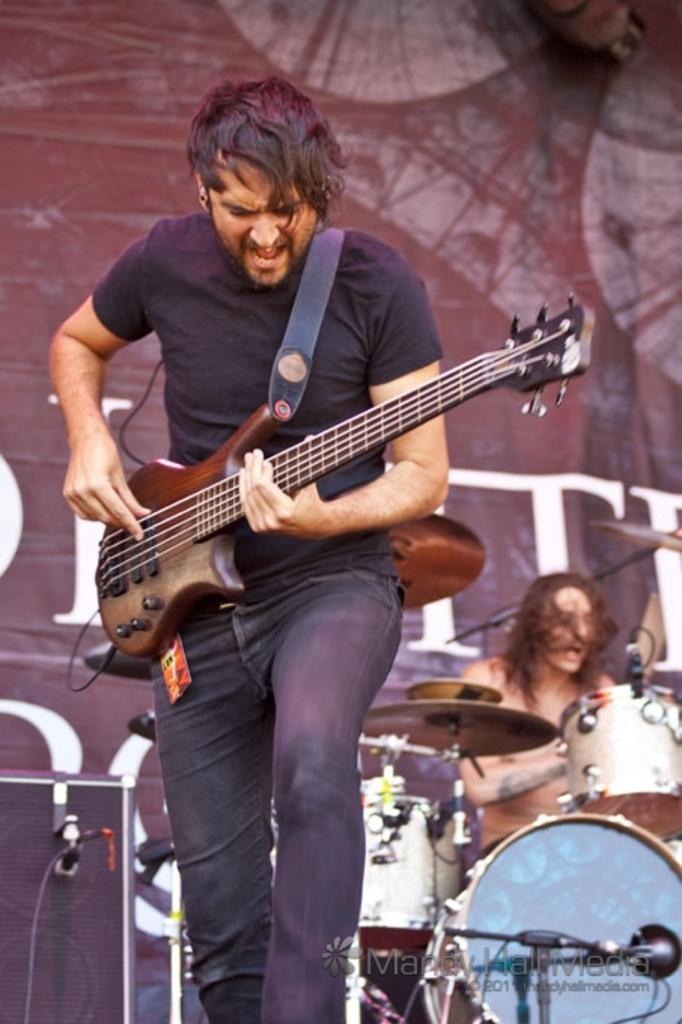How would you summarize this image in a sentence or two? This image is clicked in a concert. In the front, there is a man wearing black t-shirt is playing guitar. In the background, there is a man sitting and playing drums. In the background, there is a banner. 